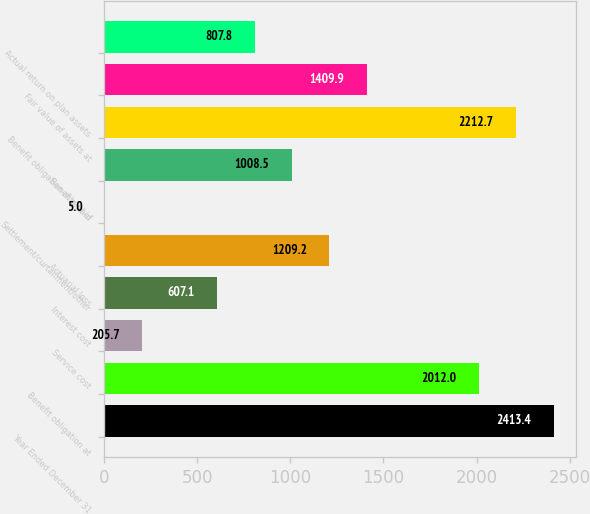Convert chart to OTSL. <chart><loc_0><loc_0><loc_500><loc_500><bar_chart><fcel>Year Ended December 31<fcel>Benefit obligation at<fcel>Service cost<fcel>Interest cost<fcel>Actuarial loss<fcel>Settlement/curtailment/other<fcel>Benefits paid<fcel>Benefit obligation at end of<fcel>Fair value of assets at<fcel>Actual return on plan assets<nl><fcel>2413.4<fcel>2012<fcel>205.7<fcel>607.1<fcel>1209.2<fcel>5<fcel>1008.5<fcel>2212.7<fcel>1409.9<fcel>807.8<nl></chart> 